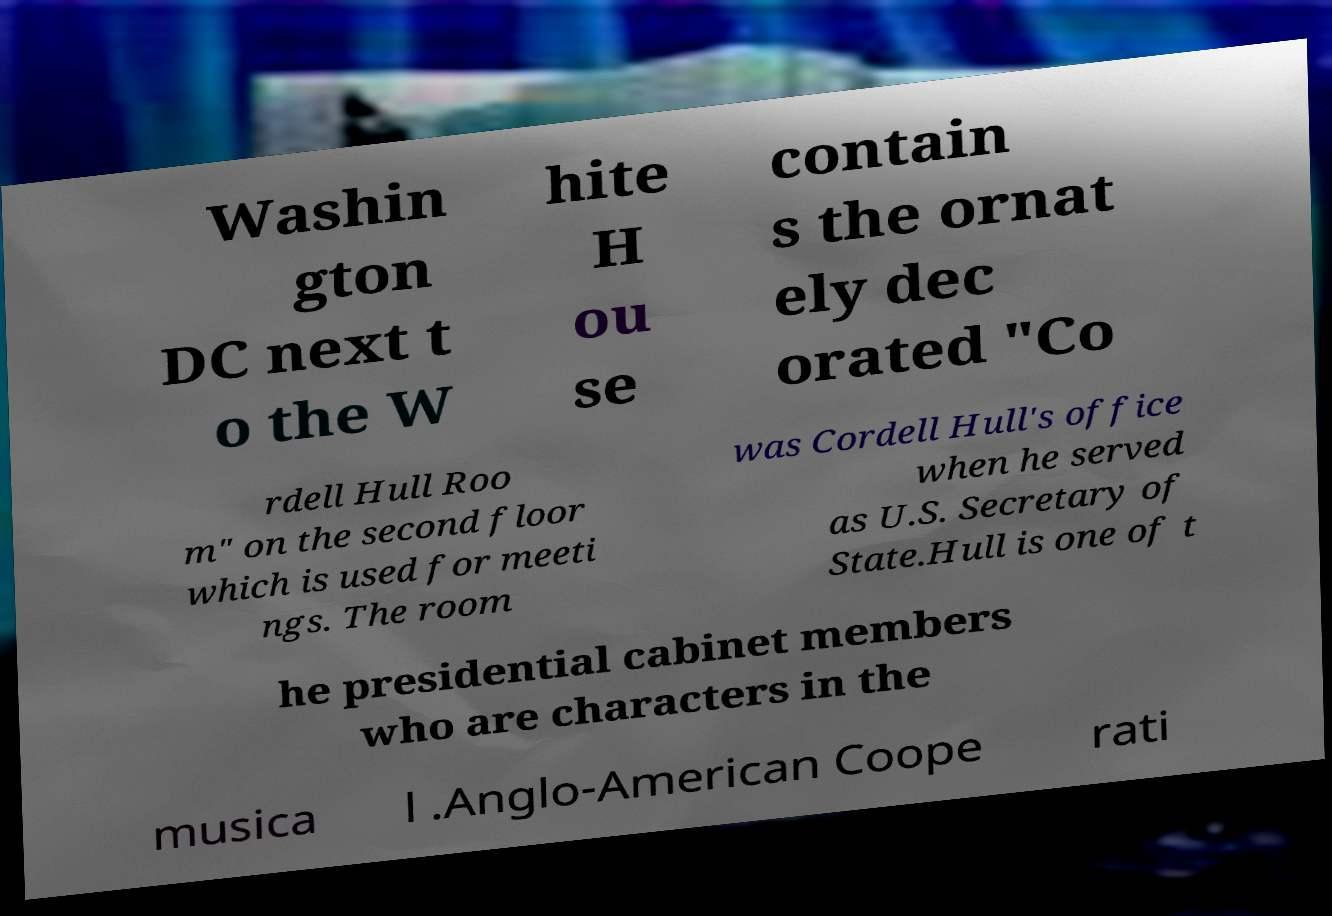Please identify and transcribe the text found in this image. Washin gton DC next t o the W hite H ou se contain s the ornat ely dec orated "Co rdell Hull Roo m" on the second floor which is used for meeti ngs. The room was Cordell Hull's office when he served as U.S. Secretary of State.Hull is one of t he presidential cabinet members who are characters in the musica l .Anglo-American Coope rati 